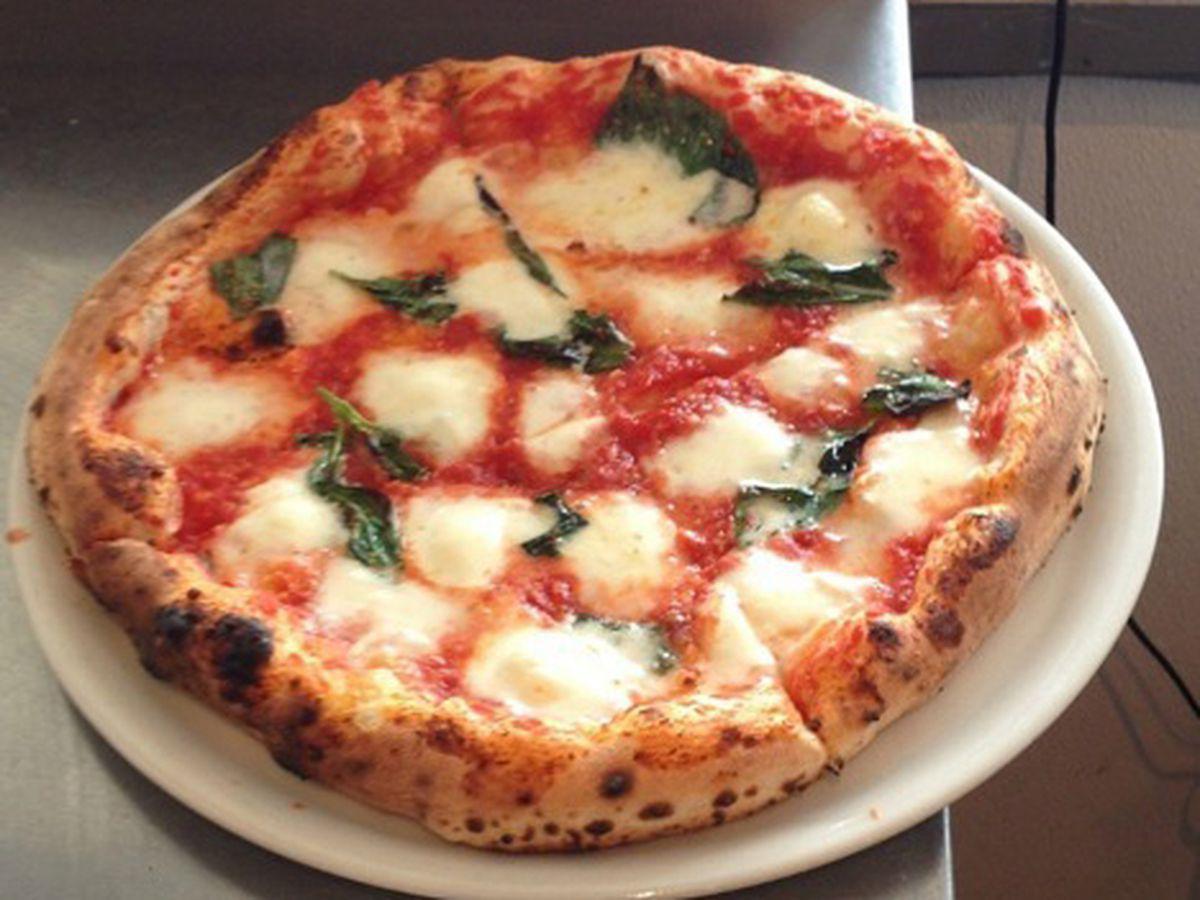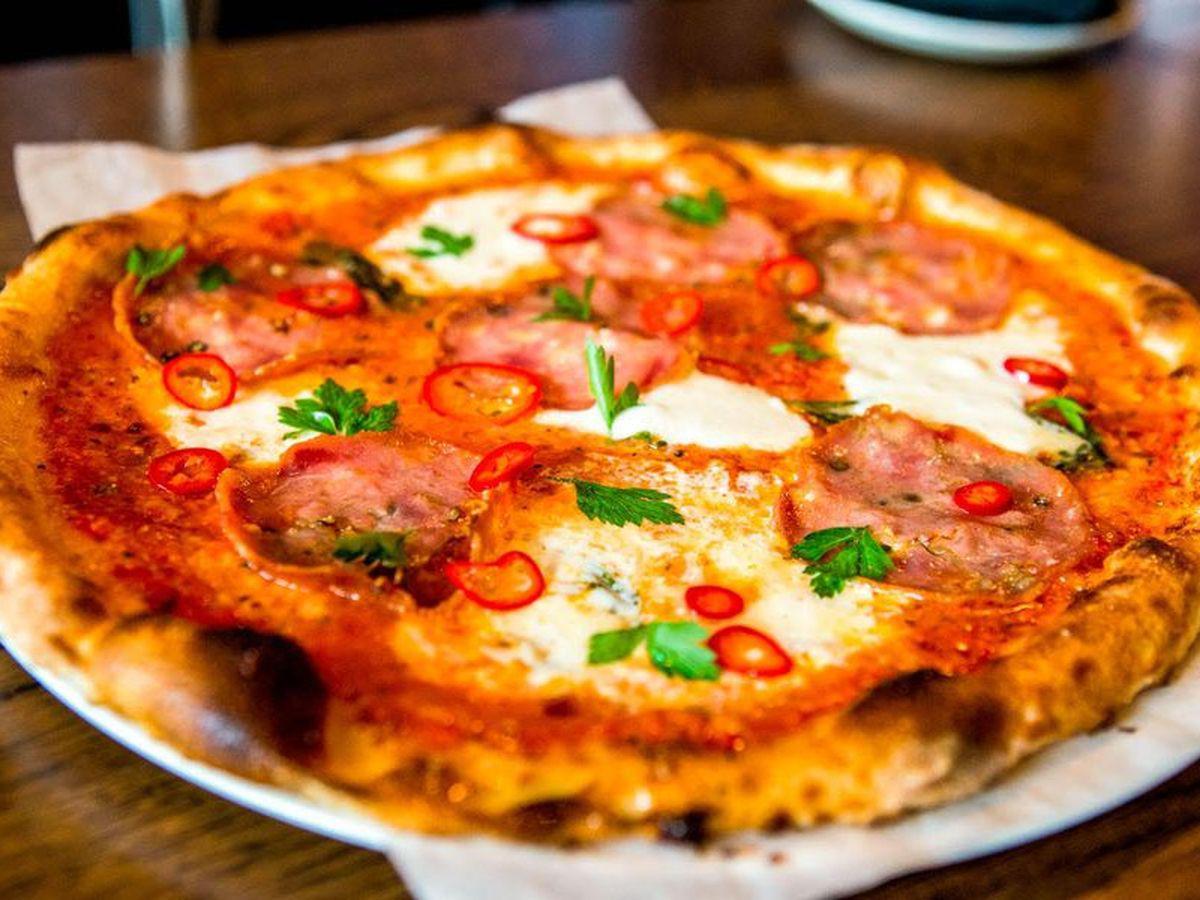The first image is the image on the left, the second image is the image on the right. Evaluate the accuracy of this statement regarding the images: "Both pizzas are cut into slices.". Is it true? Answer yes or no. No. The first image is the image on the left, the second image is the image on the right. Examine the images to the left and right. Is the description "Neither pizza is in a pan with sides, one is a New York style thin pizza, the other is a Chicago style deep dish." accurate? Answer yes or no. No. 